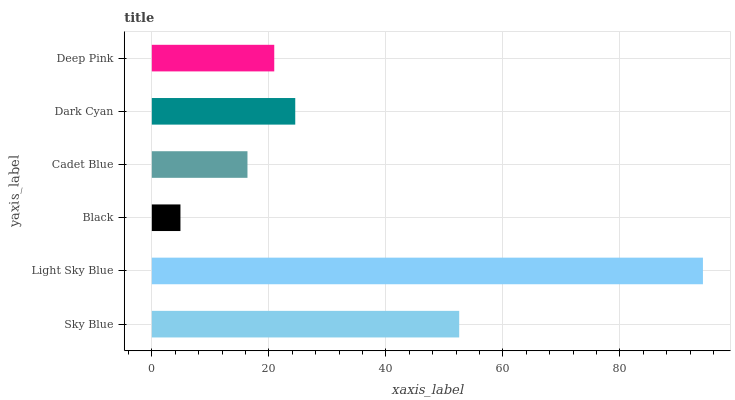Is Black the minimum?
Answer yes or no. Yes. Is Light Sky Blue the maximum?
Answer yes or no. Yes. Is Light Sky Blue the minimum?
Answer yes or no. No. Is Black the maximum?
Answer yes or no. No. Is Light Sky Blue greater than Black?
Answer yes or no. Yes. Is Black less than Light Sky Blue?
Answer yes or no. Yes. Is Black greater than Light Sky Blue?
Answer yes or no. No. Is Light Sky Blue less than Black?
Answer yes or no. No. Is Dark Cyan the high median?
Answer yes or no. Yes. Is Deep Pink the low median?
Answer yes or no. Yes. Is Black the high median?
Answer yes or no. No. Is Cadet Blue the low median?
Answer yes or no. No. 